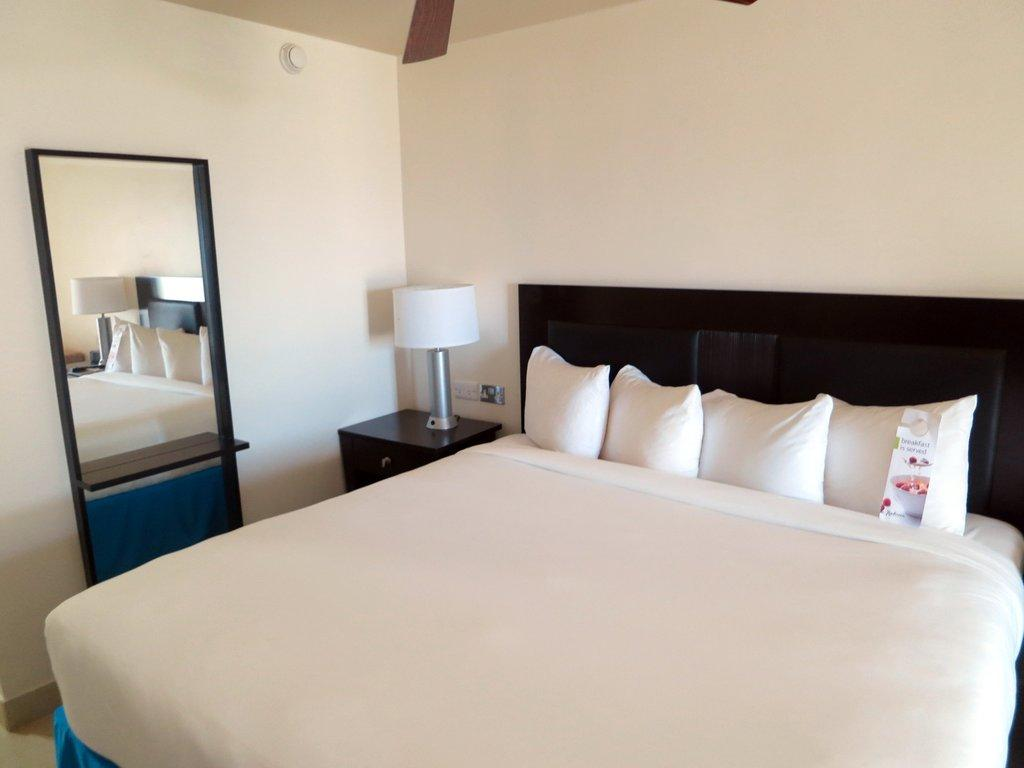What is located at the bottom of the image? There is a bed at the bottom of the image. What can be seen on the right side of the bed? There are pillows on the right side of the bed. What is in the middle of the image? There is a lamp in the middle of the image. What is on the left side of the image? There is a mirror on the left side of the image. How many cows are visible in the image? There are no cows present in the image. What type of art is hanging on the wall in the image? There is no art visible in the image; only a bed, pillows, a lamp, and a mirror are present. 